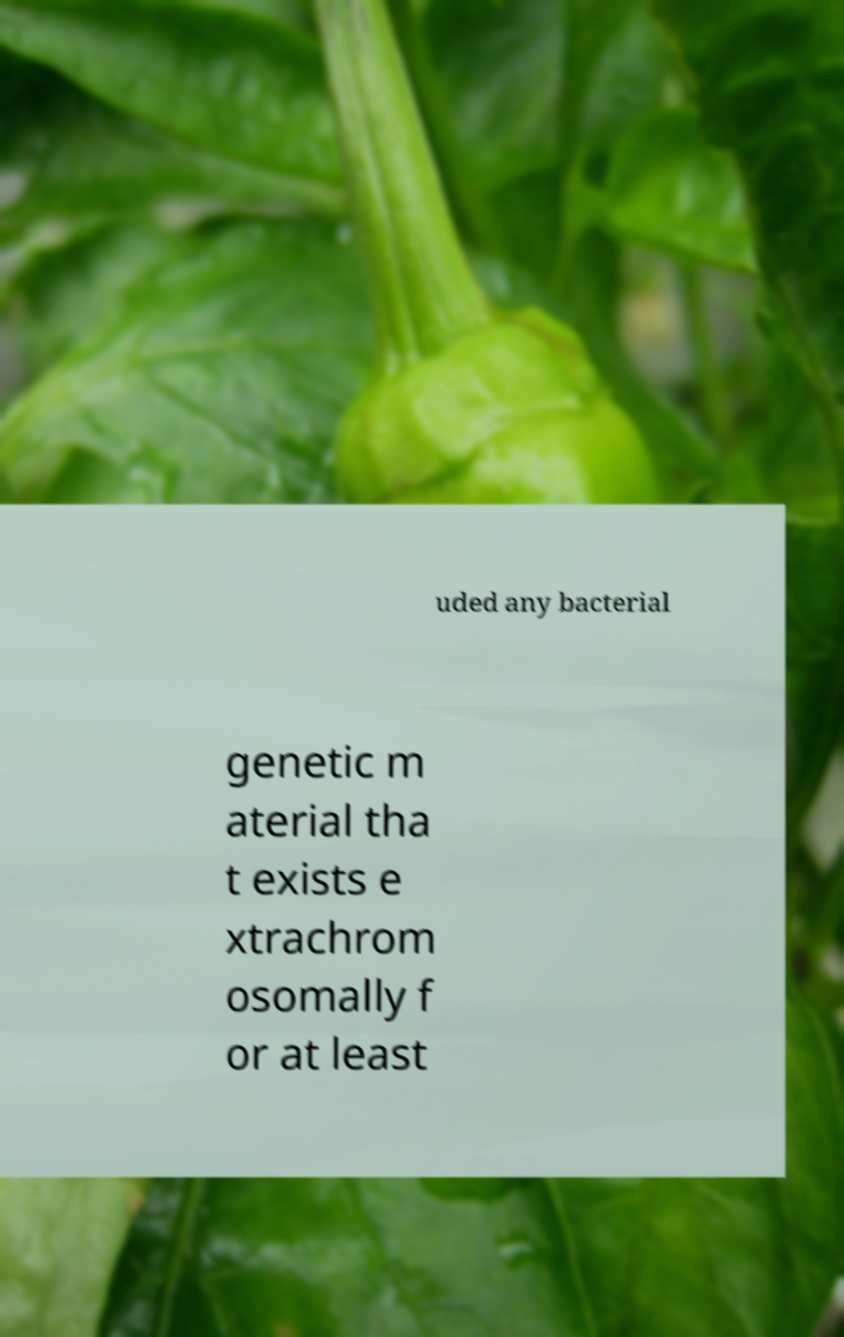Can you accurately transcribe the text from the provided image for me? uded any bacterial genetic m aterial tha t exists e xtrachrom osomally f or at least 